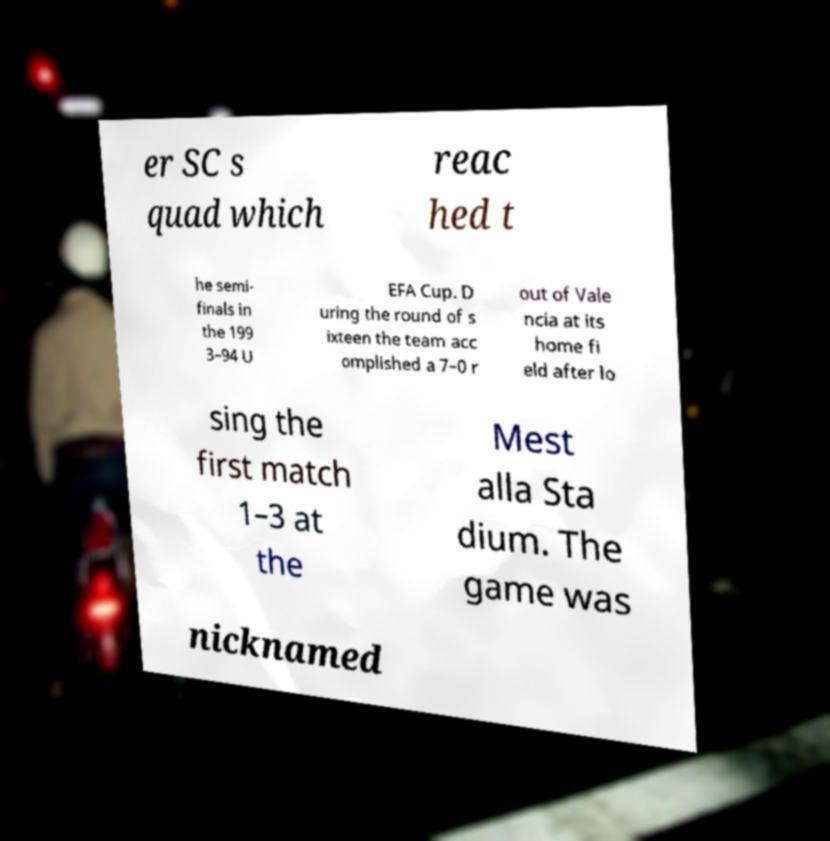Can you accurately transcribe the text from the provided image for me? er SC s quad which reac hed t he semi- finals in the 199 3–94 U EFA Cup. D uring the round of s ixteen the team acc omplished a 7–0 r out of Vale ncia at its home fi eld after lo sing the first match 1–3 at the Mest alla Sta dium. The game was nicknamed 